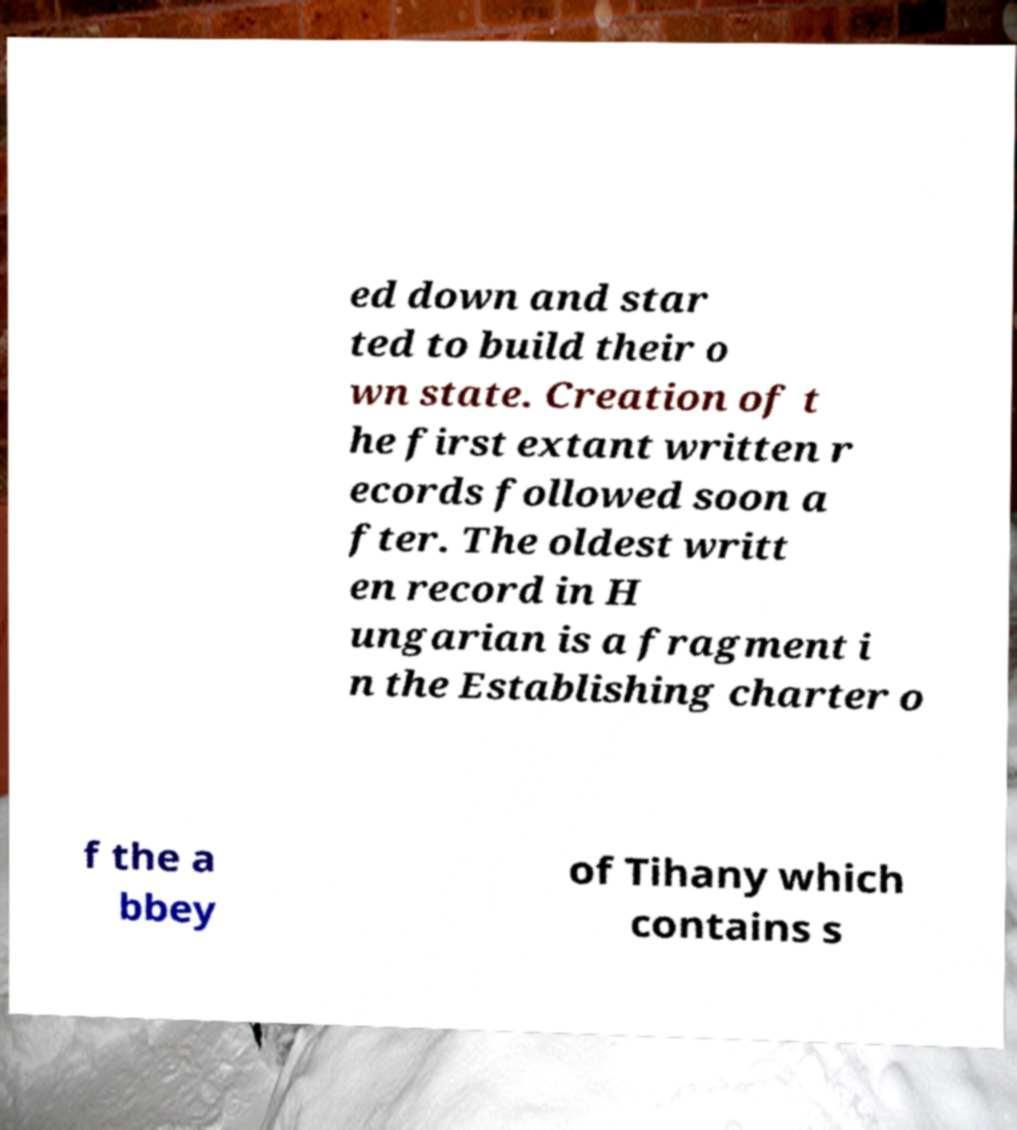Please read and relay the text visible in this image. What does it say? ed down and star ted to build their o wn state. Creation of t he first extant written r ecords followed soon a fter. The oldest writt en record in H ungarian is a fragment i n the Establishing charter o f the a bbey of Tihany which contains s 